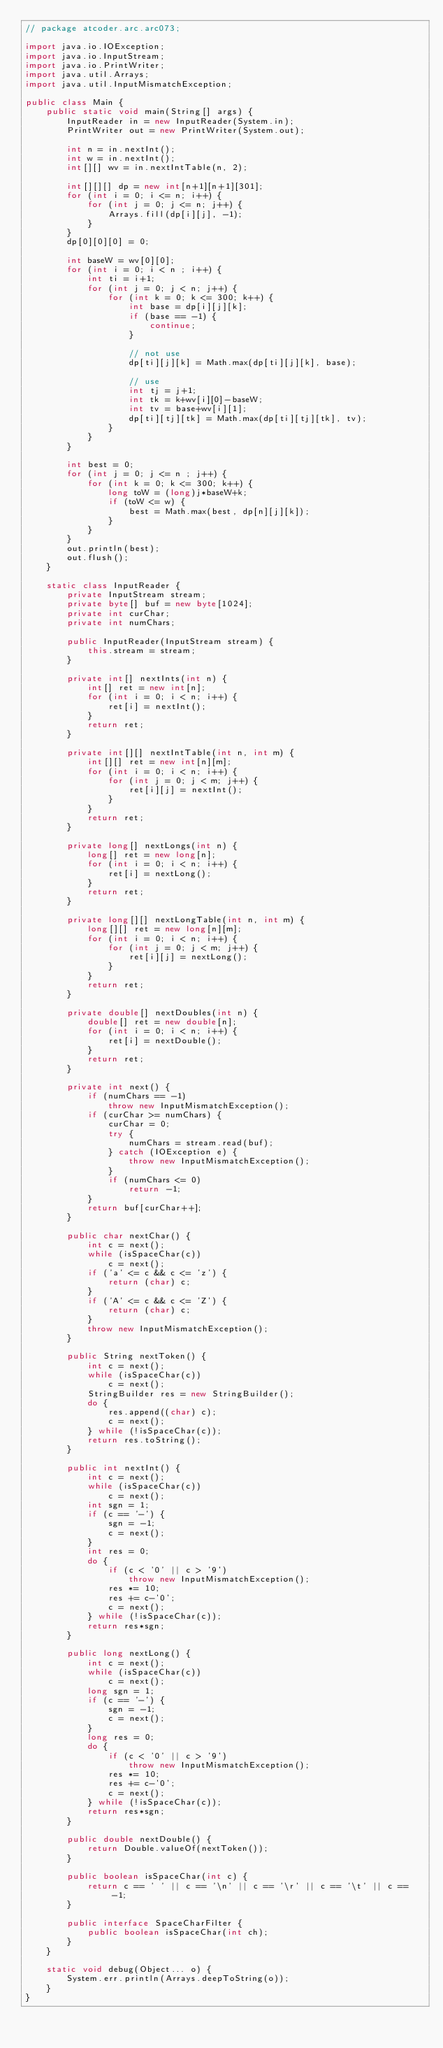Convert code to text. <code><loc_0><loc_0><loc_500><loc_500><_Java_>// package atcoder.arc.arc073;

import java.io.IOException;
import java.io.InputStream;
import java.io.PrintWriter;
import java.util.Arrays;
import java.util.InputMismatchException;

public class Main {
    public static void main(String[] args) {
        InputReader in = new InputReader(System.in);
        PrintWriter out = new PrintWriter(System.out);

        int n = in.nextInt();
        int w = in.nextInt();
        int[][] wv = in.nextIntTable(n, 2);

        int[][][] dp = new int[n+1][n+1][301];
        for (int i = 0; i <= n; i++) {
            for (int j = 0; j <= n; j++) {
                Arrays.fill(dp[i][j], -1);
            }
        }
        dp[0][0][0] = 0;

        int baseW = wv[0][0];
        for (int i = 0; i < n ; i++) {
            int ti = i+1;
            for (int j = 0; j < n; j++) {
                for (int k = 0; k <= 300; k++) {
                    int base = dp[i][j][k];
                    if (base == -1) {
                        continue;
                    }

                    // not use
                    dp[ti][j][k] = Math.max(dp[ti][j][k], base);

                    // use
                    int tj = j+1;
                    int tk = k+wv[i][0]-baseW;
                    int tv = base+wv[i][1];
                    dp[ti][tj][tk] = Math.max(dp[ti][tj][tk], tv);
                }
            }
        }

        int best = 0;
        for (int j = 0; j <= n ; j++) {
            for (int k = 0; k <= 300; k++) {
                long toW = (long)j*baseW+k;
                if (toW <= w) {
                    best = Math.max(best, dp[n][j][k]);
                }
            }
        }
        out.println(best);
        out.flush();
    }

    static class InputReader {
        private InputStream stream;
        private byte[] buf = new byte[1024];
        private int curChar;
        private int numChars;

        public InputReader(InputStream stream) {
            this.stream = stream;
        }

        private int[] nextInts(int n) {
            int[] ret = new int[n];
            for (int i = 0; i < n; i++) {
                ret[i] = nextInt();
            }
            return ret;
        }

        private int[][] nextIntTable(int n, int m) {
            int[][] ret = new int[n][m];
            for (int i = 0; i < n; i++) {
                for (int j = 0; j < m; j++) {
                    ret[i][j] = nextInt();
                }
            }
            return ret;
        }

        private long[] nextLongs(int n) {
            long[] ret = new long[n];
            for (int i = 0; i < n; i++) {
                ret[i] = nextLong();
            }
            return ret;
        }

        private long[][] nextLongTable(int n, int m) {
            long[][] ret = new long[n][m];
            for (int i = 0; i < n; i++) {
                for (int j = 0; j < m; j++) {
                    ret[i][j] = nextLong();
                }
            }
            return ret;
        }

        private double[] nextDoubles(int n) {
            double[] ret = new double[n];
            for (int i = 0; i < n; i++) {
                ret[i] = nextDouble();
            }
            return ret;
        }

        private int next() {
            if (numChars == -1)
                throw new InputMismatchException();
            if (curChar >= numChars) {
                curChar = 0;
                try {
                    numChars = stream.read(buf);
                } catch (IOException e) {
                    throw new InputMismatchException();
                }
                if (numChars <= 0)
                    return -1;
            }
            return buf[curChar++];
        }

        public char nextChar() {
            int c = next();
            while (isSpaceChar(c))
                c = next();
            if ('a' <= c && c <= 'z') {
                return (char) c;
            }
            if ('A' <= c && c <= 'Z') {
                return (char) c;
            }
            throw new InputMismatchException();
        }

        public String nextToken() {
            int c = next();
            while (isSpaceChar(c))
                c = next();
            StringBuilder res = new StringBuilder();
            do {
                res.append((char) c);
                c = next();
            } while (!isSpaceChar(c));
            return res.toString();
        }

        public int nextInt() {
            int c = next();
            while (isSpaceChar(c))
                c = next();
            int sgn = 1;
            if (c == '-') {
                sgn = -1;
                c = next();
            }
            int res = 0;
            do {
                if (c < '0' || c > '9')
                    throw new InputMismatchException();
                res *= 10;
                res += c-'0';
                c = next();
            } while (!isSpaceChar(c));
            return res*sgn;
        }

        public long nextLong() {
            int c = next();
            while (isSpaceChar(c))
                c = next();
            long sgn = 1;
            if (c == '-') {
                sgn = -1;
                c = next();
            }
            long res = 0;
            do {
                if (c < '0' || c > '9')
                    throw new InputMismatchException();
                res *= 10;
                res += c-'0';
                c = next();
            } while (!isSpaceChar(c));
            return res*sgn;
        }

        public double nextDouble() {
            return Double.valueOf(nextToken());
        }

        public boolean isSpaceChar(int c) {
            return c == ' ' || c == '\n' || c == '\r' || c == '\t' || c == -1;
        }

        public interface SpaceCharFilter {
            public boolean isSpaceChar(int ch);
        }
    }

    static void debug(Object... o) {
        System.err.println(Arrays.deepToString(o));
    }
}
</code> 